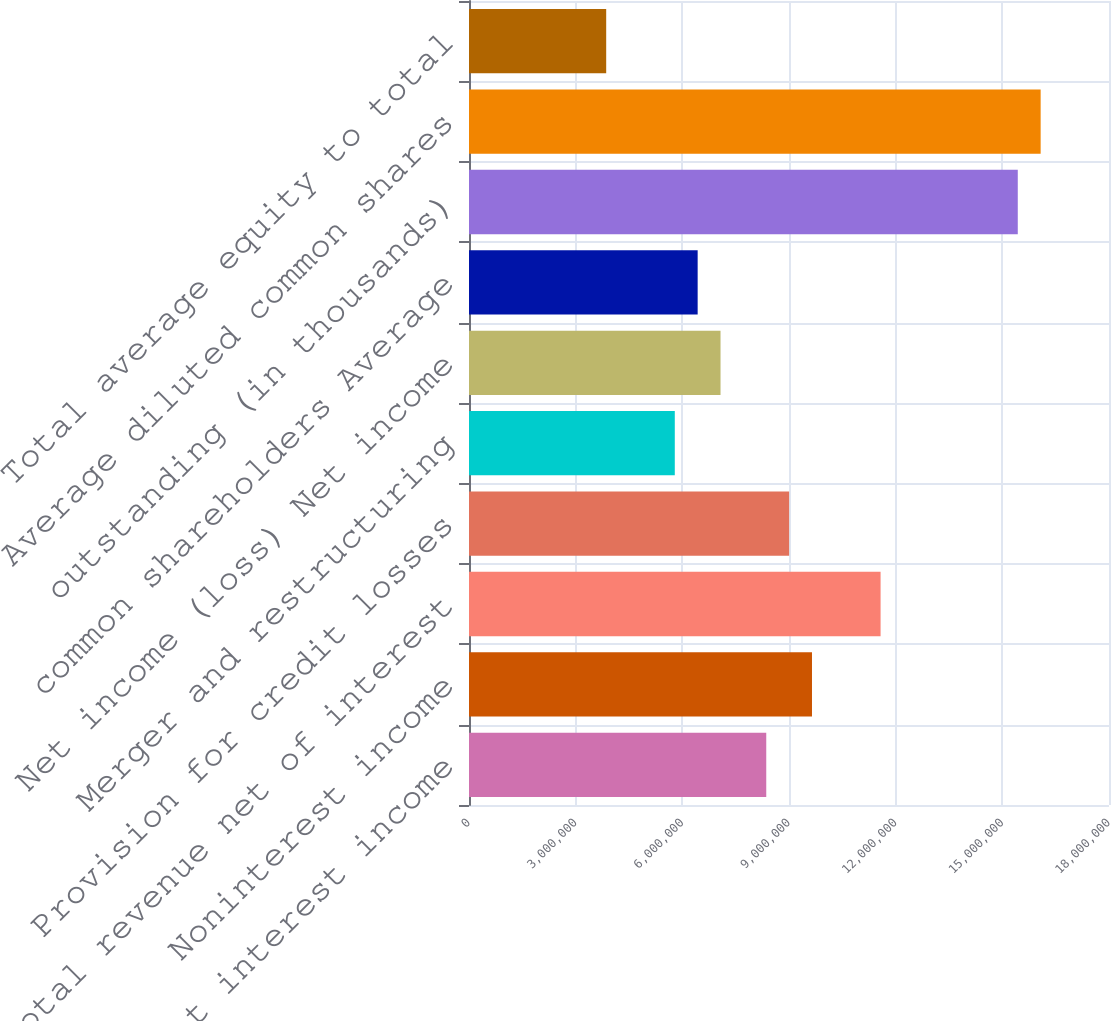<chart> <loc_0><loc_0><loc_500><loc_500><bar_chart><fcel>Net interest income<fcel>Noninterest income<fcel>Total revenue net of interest<fcel>Provision for credit losses<fcel>Merger and restructuring<fcel>Net income (loss) Net income<fcel>common shareholders Average<fcel>outstanding (in thousands)<fcel>Average diluted common shares<fcel>Total average equity to total<nl><fcel>8.36034e+06<fcel>9.64654e+06<fcel>1.15758e+07<fcel>9.00344e+06<fcel>5.78792e+06<fcel>7.07413e+06<fcel>6.43103e+06<fcel>1.54345e+07<fcel>1.60776e+07<fcel>3.85862e+06<nl></chart> 